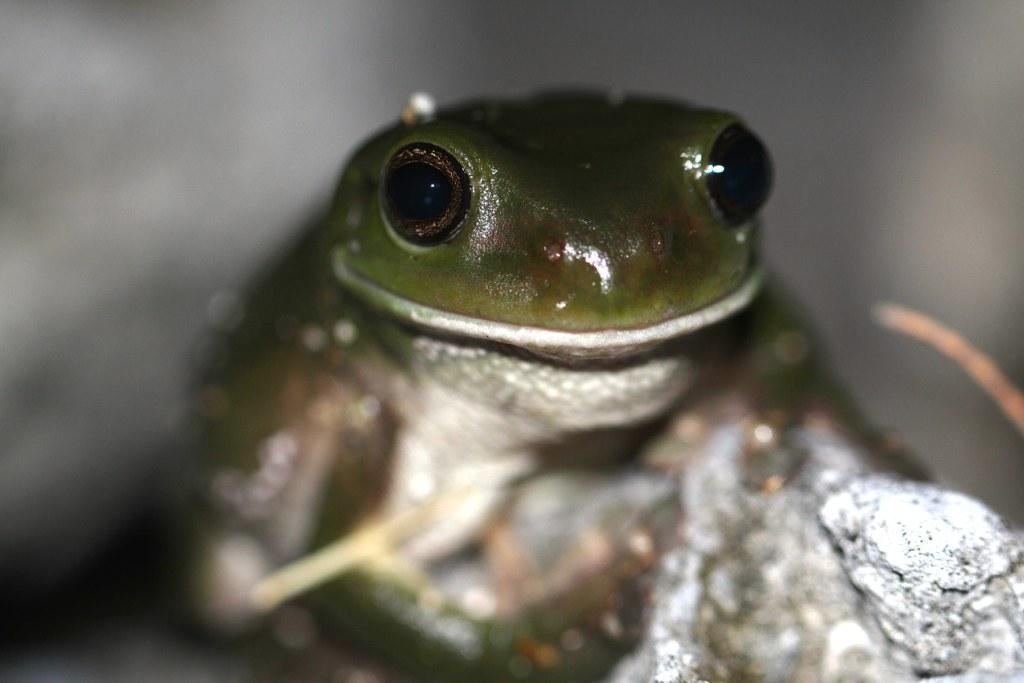What type of animal is in the picture? There is a green frog in the picture. What color are the frog's eyes? The frog has black big eyes. Where is the frog sitting? The frog is sitting on a stone. How would you describe the background of the image? The background of the image is blurred. What decision is the frog making in the image? There is no indication in the image that the frog is making a decision. --- Facts: 1. There is a group of people in the image. 2. The people are wearing hats. 3. The people are holding hands. 4. The background of the image is a park. Absurd Topics: parrot, bicycle, mountain Conversation: How many people are in the image? There is a group of people in the image. What are the people wearing on their heads? The people are wearing hats. What are the people doing with their hands? The people are holding hands. What can be seen in the background of the image? The background of the image is a park. Reasoning: Let's think step by step in order to produce the conversation. We start by identifying the main subject in the image, which is the group of people. Then, we expand the conversation to include specific details about the people, such as their hats and what they are doing with their hands. Finally, we describe the background of the image, which is a park. Each question is designed to elicit a specific detail about the image that is known from the provided facts. Absurd Question/Answer: Can you see a parrot flying in the image? There is no parrot present in the image. --- Facts: 1. There is a car in the image. 2. The car is red. 3. The car has four wheels. 4. The car has a sunroof. 5. The car is parked on the street. Absurd Topics: bird, ocean, volcano Conversation: What type of vehicle is in the image? There is a car in the image. What color is the car? The car is red. How many wheels does the car have? The car has four wheels. What feature does the car have on its roof? The car has a sunroof. Where is the car located in the image? The car is parked on the street. Reasoning: Let's think step by step in order to produce the conversation. We start by identifying the main subject in the image, which is the car. Then, we expand the conversation to include specific details about the car, such as its color, number of wheels, and the presence of a sunroof. Finally, 